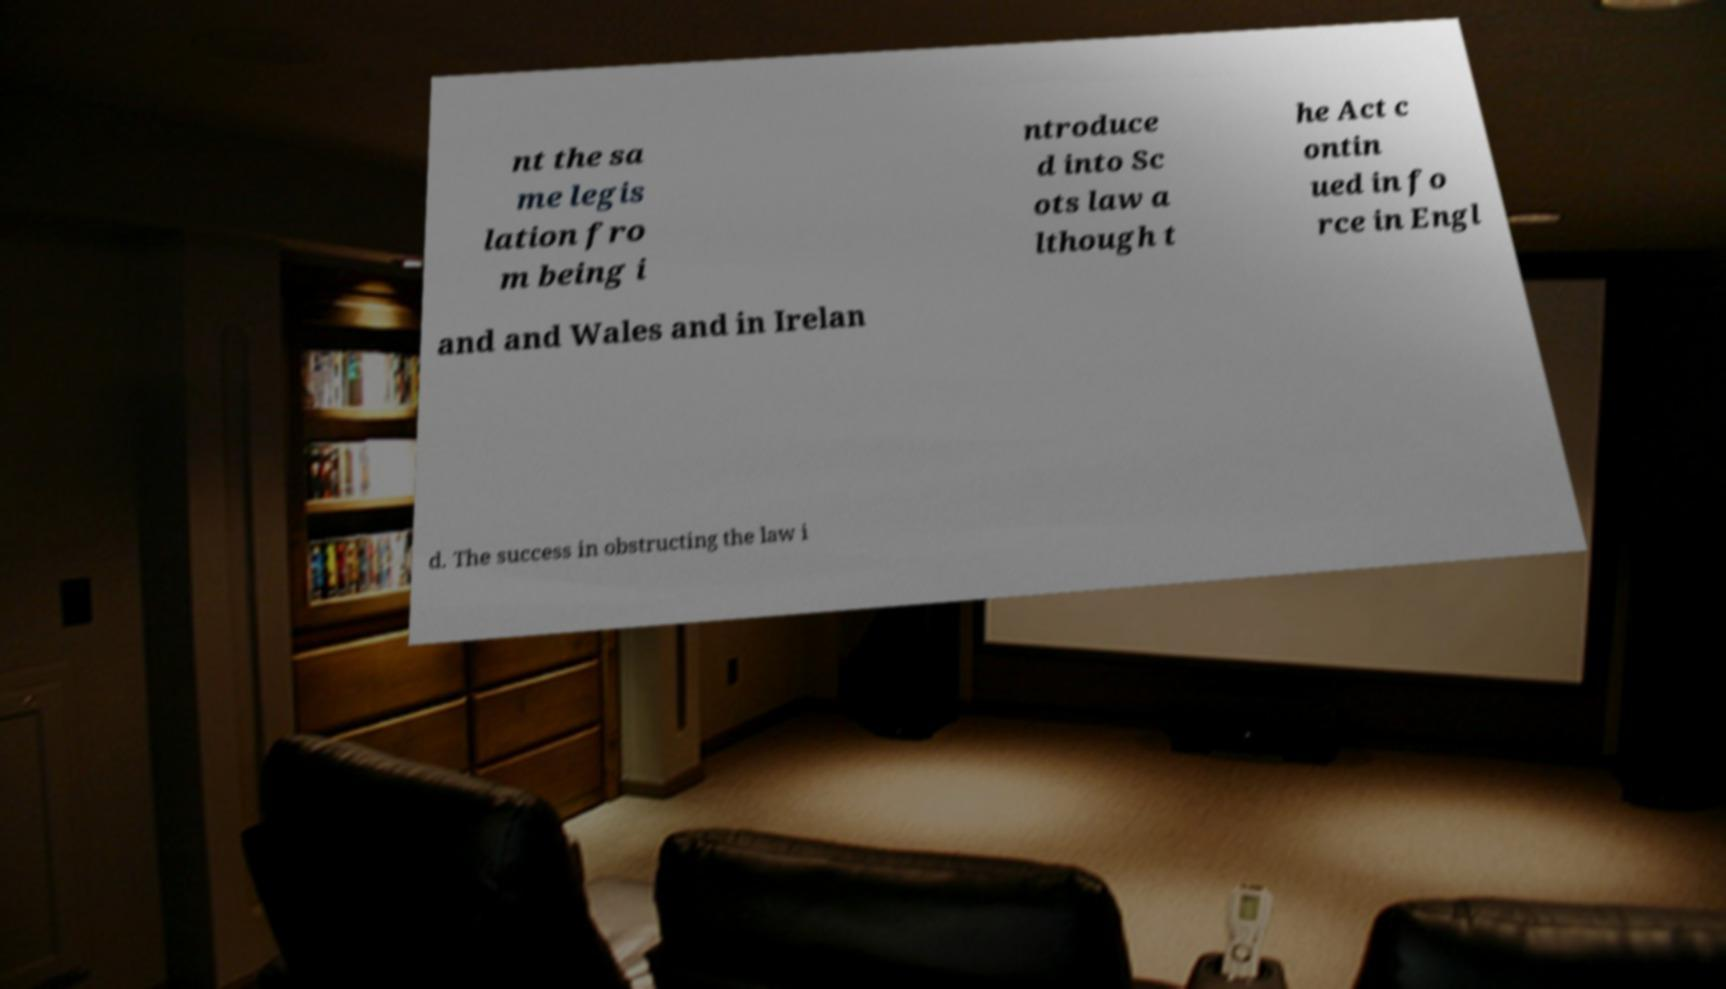For documentation purposes, I need the text within this image transcribed. Could you provide that? nt the sa me legis lation fro m being i ntroduce d into Sc ots law a lthough t he Act c ontin ued in fo rce in Engl and and Wales and in Irelan d. The success in obstructing the law i 